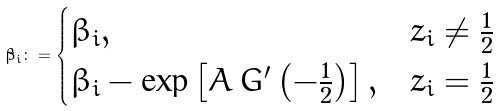<formula> <loc_0><loc_0><loc_500><loc_500>\tilde { \beta } _ { i } \colon = \begin{cases} \beta _ { i } , & z _ { i } \ne \frac { 1 } { 2 } \\ \beta _ { i } - \exp \left [ A \, G ^ { \prime } \left ( - \frac { 1 } { 2 } \right ) \right ] , & z _ { i } = \frac { 1 } { 2 } \end{cases}</formula> 